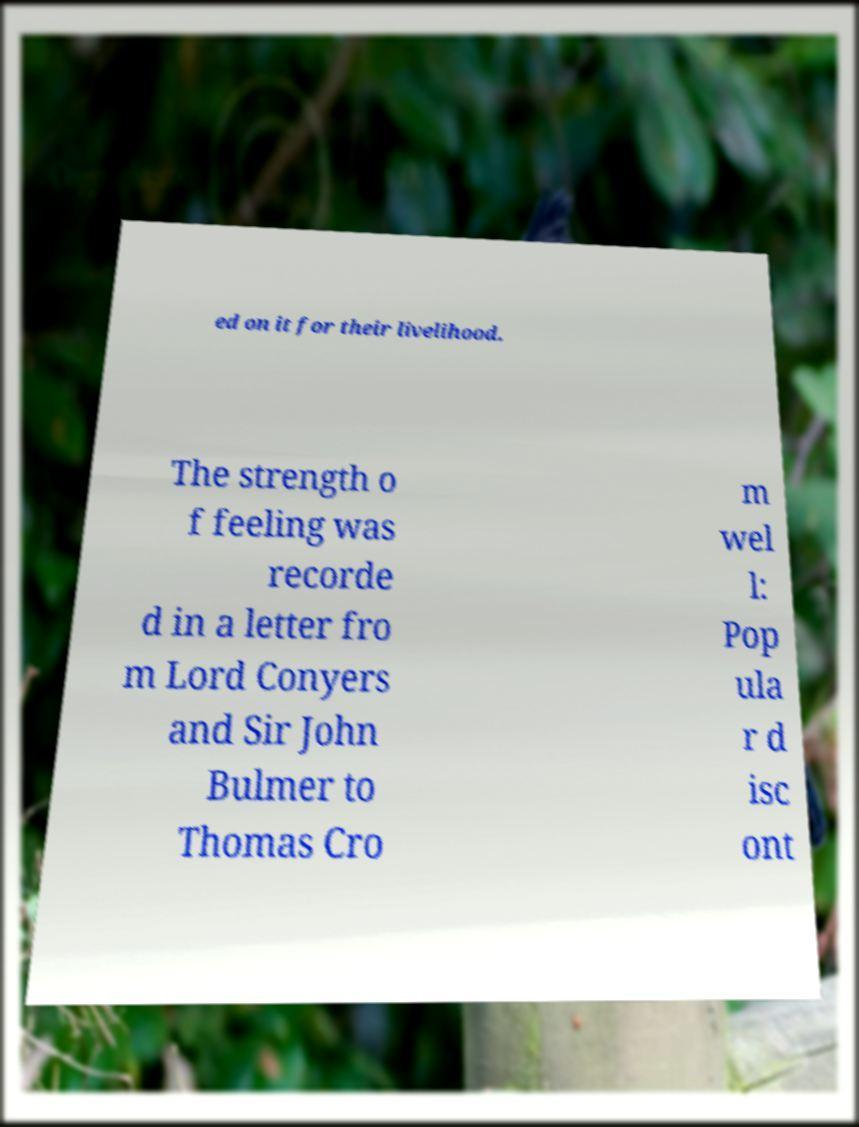Could you extract and type out the text from this image? ed on it for their livelihood. The strength o f feeling was recorde d in a letter fro m Lord Conyers and Sir John Bulmer to Thomas Cro m wel l: Pop ula r d isc ont 